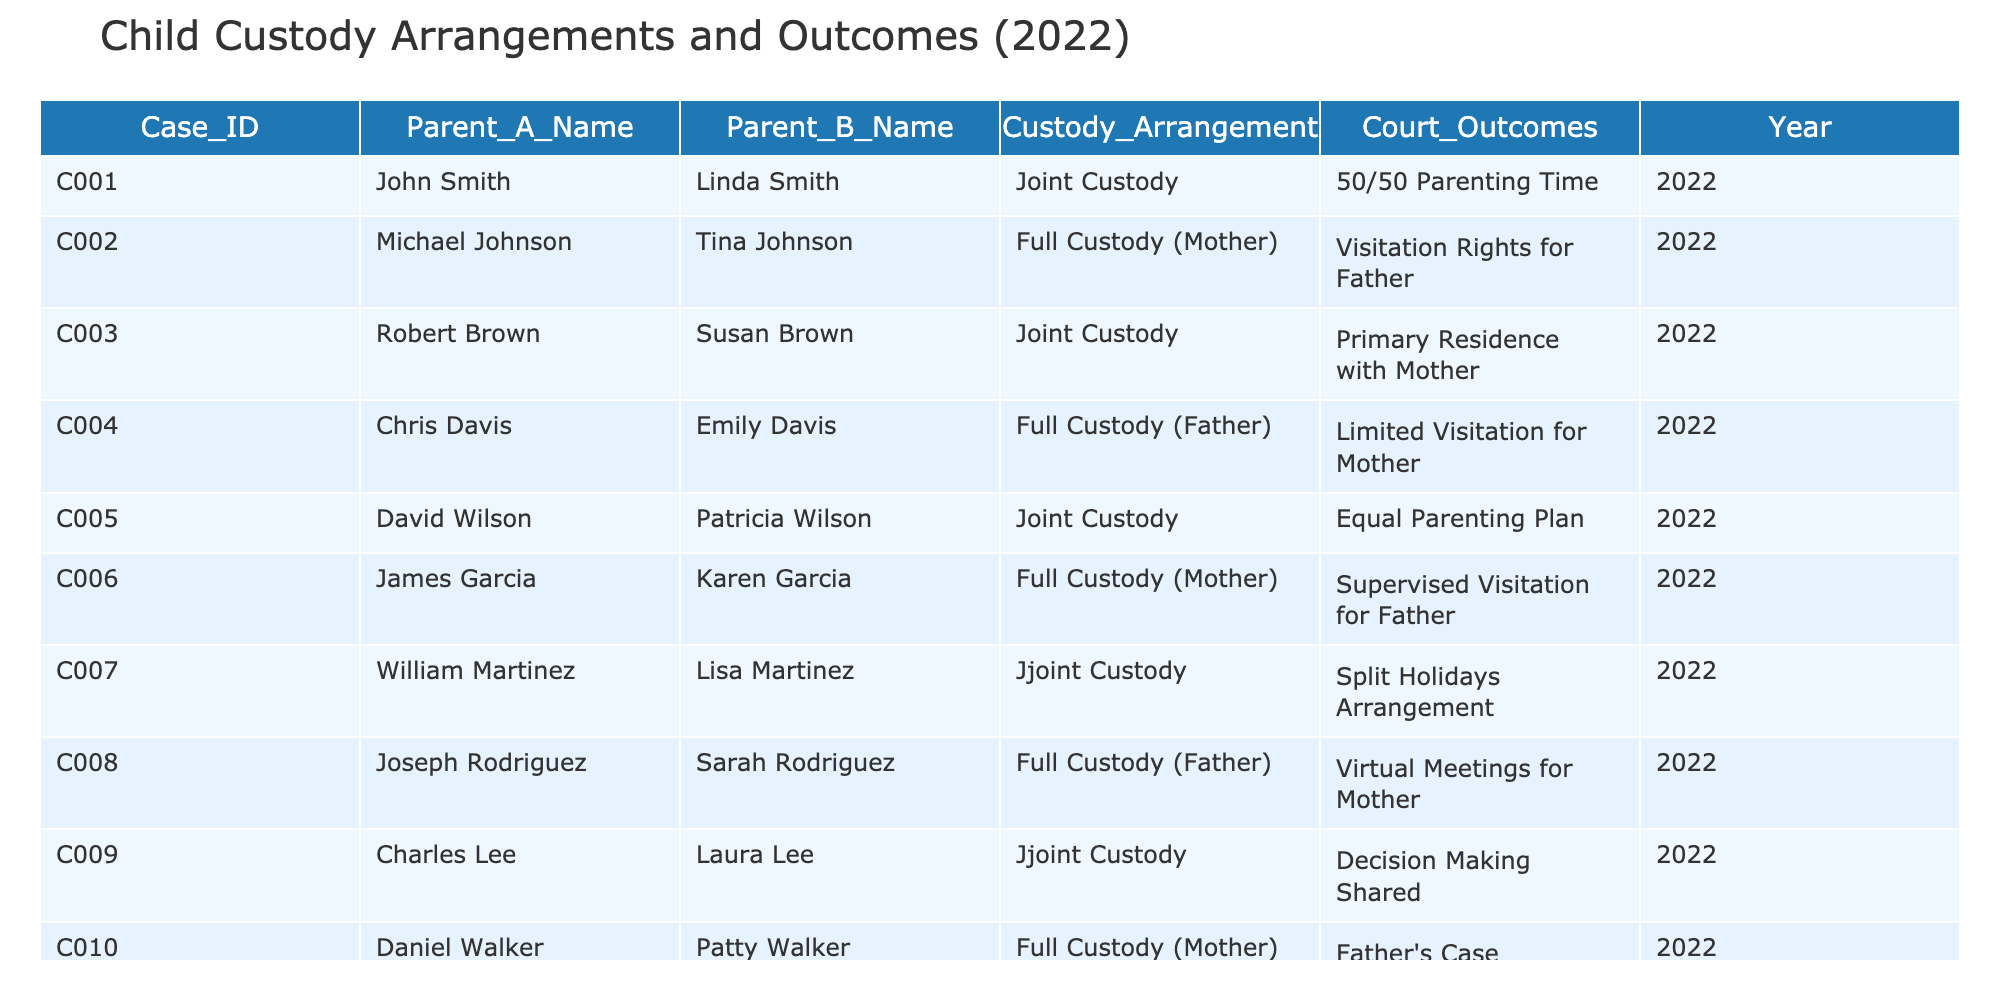What is the custody arrangement in case C001? The custody arrangement for case C001 is listed in the table under the "Custody Arrangement" column, where it states "Joint Custody."
Answer: Joint Custody How many cases were granted full custody to the mother? By looking at the "Custody Arrangement" column, there are three cases (C002, C006, and C010) where full custody was granted to the mother.
Answer: 3 What percentage of cases resulted in joint custody arrangements? There are a total of 10 cases, and 5 of them have joint custody arrangements. To find the percentage, we calculate (5/10) * 100 = 50%.
Answer: 50% Did any father receive full custody alongside visitation rights for the mother? In reviewing the table, it shows that case C004 granted full custody to the father, but it only allowed limited visitation for the mother, so the answer is no.
Answer: No Which parent has the primary residence for joint custody in case C003? The "Court Outcomes" column specifies "Primary Residence with Mother" for case C003, indicating that the mother has the primary residence.
Answer: Mother Among the cases with full custody awarded to the mother, how many allowed visitation for the father? There are three full custody cases (C002, C006, and C010). Of these, case C002 has visitation rights for the father, and case C006 has supervised visitation, totaling two cases.
Answer: 2 What is the relationship between the custody arrangement and court outcomes for cases with joint custody? By examining cases C001, C003, C005, C007, and C009 under joint custody, their outcomes vary, including equal parenting, split holidays, and shared decision-making, indicating that joint custody results in diverse outcomes based on individual circumstances.
Answer: Diverse outcomes Which parent received the most favorable court outcome in the table? Favorable outcomes can vary by perspective, but from the cases reviewed, full custody generally is seen as favorable. Cases C002, C006, C004, and C008 show full custody decisions leaning positively for the mothers and fathers, respectively, meaning both can have favorable outcomes based on their circumstances.
Answer: Both parents can have favorable outcomes 